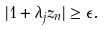<formula> <loc_0><loc_0><loc_500><loc_500>| 1 + \lambda _ { j } z _ { n } | \geq \epsilon .</formula> 